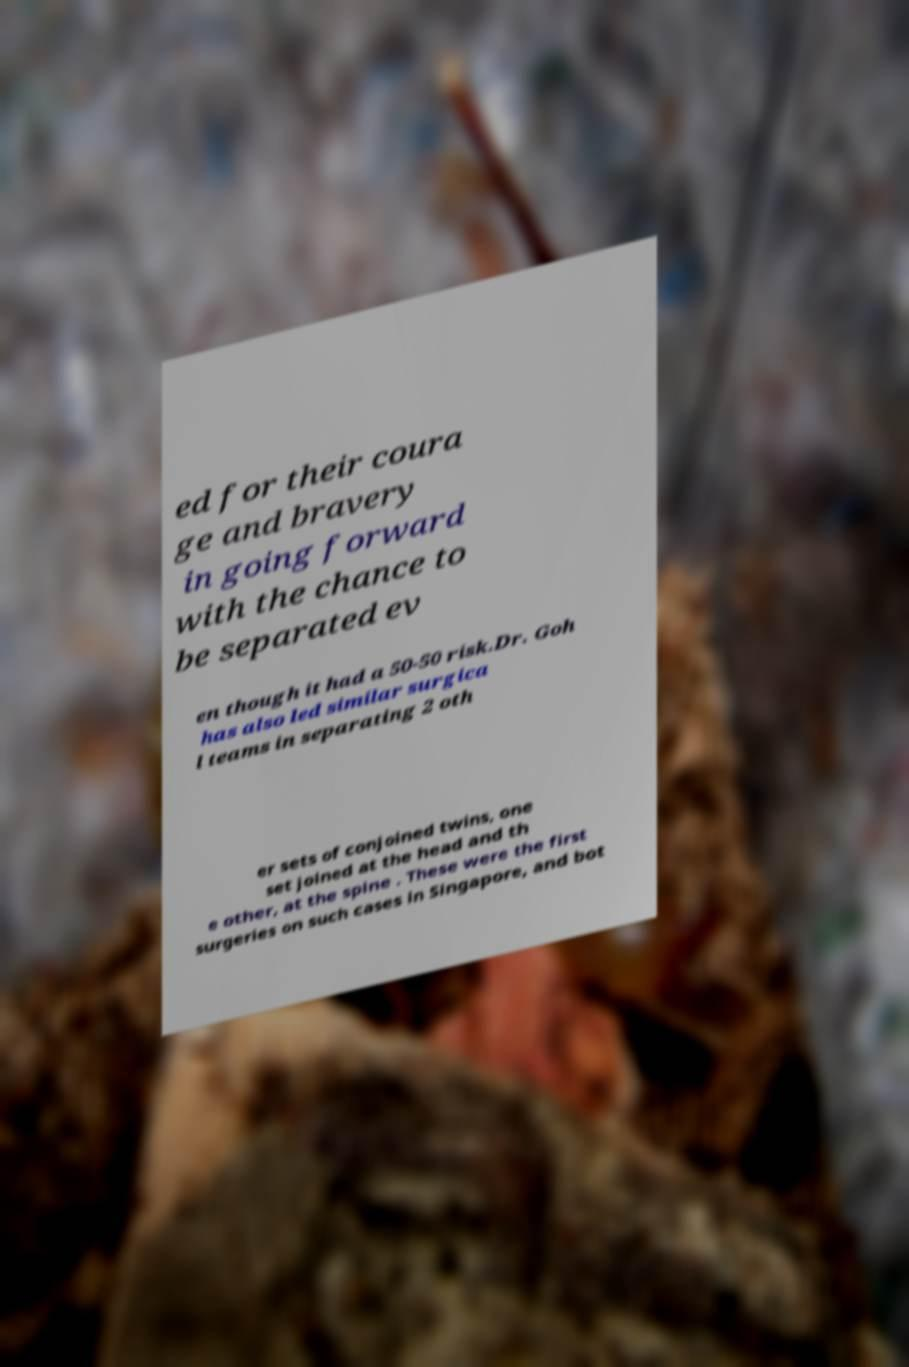Can you accurately transcribe the text from the provided image for me? ed for their coura ge and bravery in going forward with the chance to be separated ev en though it had a 50-50 risk.Dr. Goh has also led similar surgica l teams in separating 2 oth er sets of conjoined twins, one set joined at the head and th e other, at the spine . These were the first surgeries on such cases in Singapore, and bot 